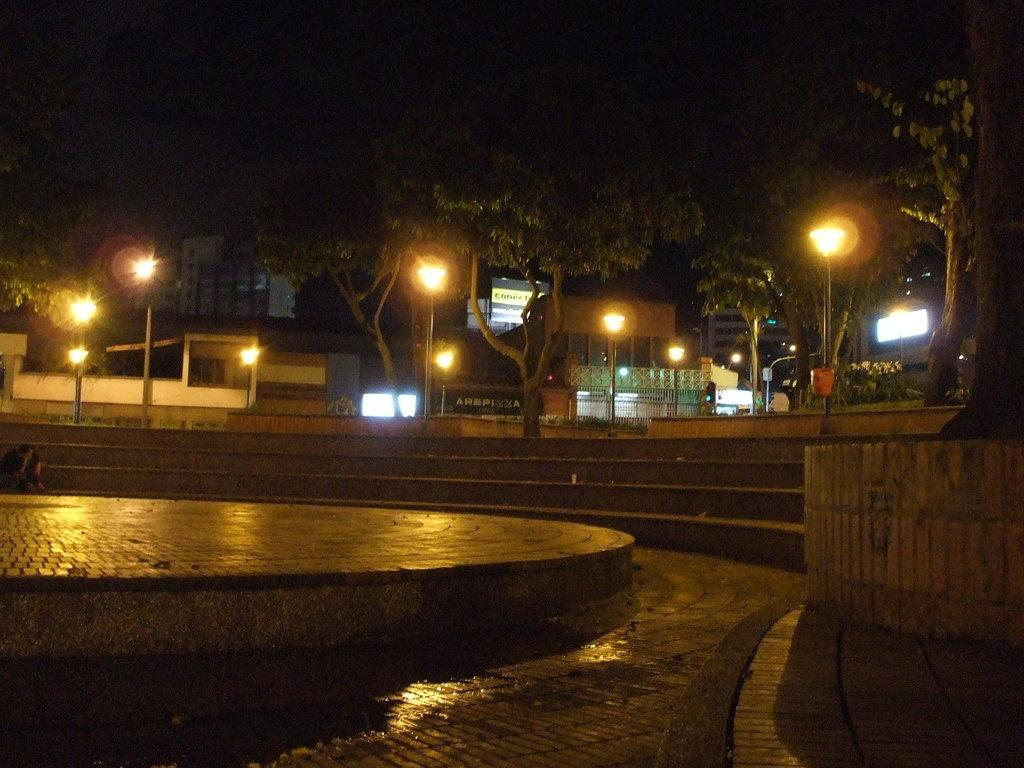What objects are present in the image that emit light? There are lights in the image. What structures can be seen supporting the lights? There are poles in the image. What celestial objects are visible in the image? Stars are visible in the image. What type of man-made structures are present in the image? There are buildings in the image. What type of natural vegetation is present in the image? There are trees in the image. How would you describe the overall lighting in the image? The background of the image is dark. What type of record can be seen spinning on a turntable in the image? There is no record or turntable present in the image. What type of coal is being used to fuel the lights in the image? There is no coal being used to fuel the lights in the image; the lights are likely powered by electricity. 